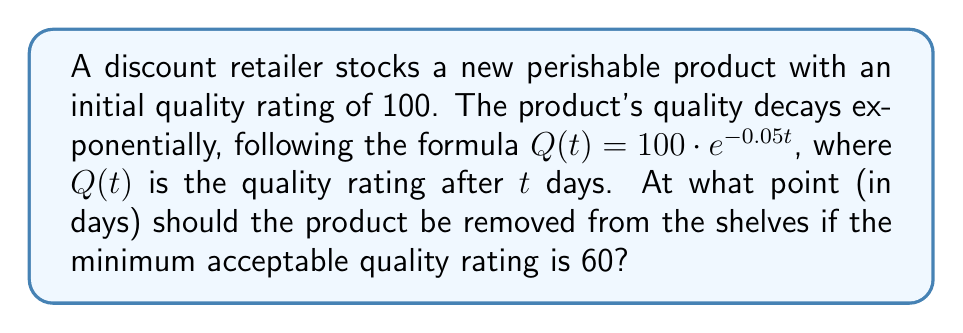Could you help me with this problem? Let's approach this step-by-step:

1) We're given the decay formula: $Q(t) = 100 \cdot e^{-0.05t}$

2) We need to find $t$ when $Q(t) = 60$

3) Let's set up the equation:
   $60 = 100 \cdot e^{-0.05t}$

4) Divide both sides by 100:
   $0.6 = e^{-0.05t}$

5) Take the natural logarithm of both sides:
   $\ln(0.6) = \ln(e^{-0.05t})$

6) Simplify the right side using the properties of logarithms:
   $\ln(0.6) = -0.05t$

7) Divide both sides by -0.05:
   $\frac{\ln(0.6)}{-0.05} = t$

8) Calculate:
   $t \approx 10.23$ days

9) Since we can't have a fraction of a day for shelf life, we round down to ensure the quality doesn't fall below 60.

Therefore, the product should be removed after 10 days.
Answer: 10 days 